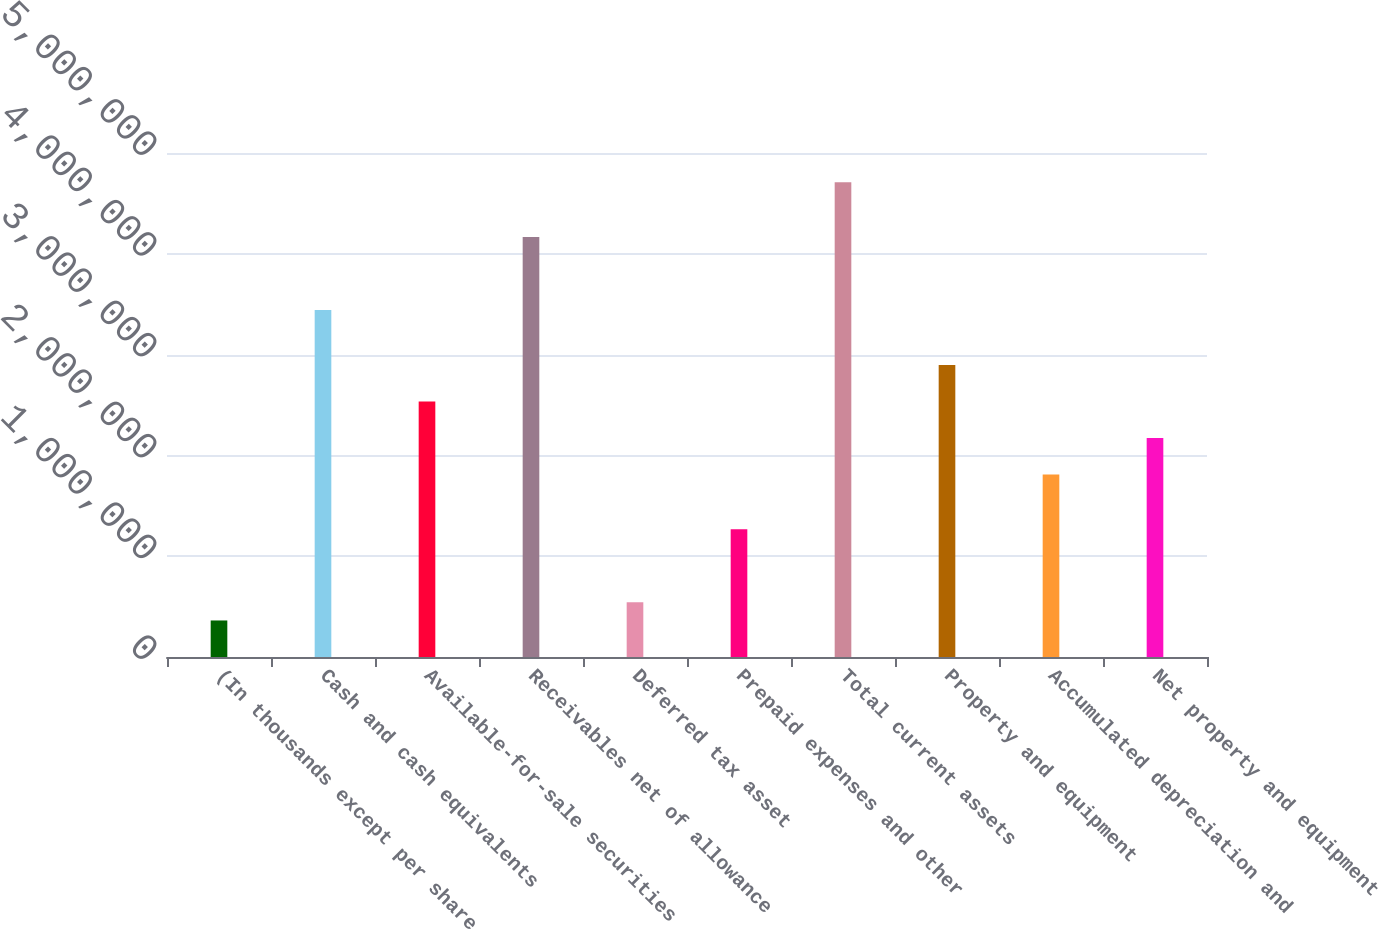Convert chart. <chart><loc_0><loc_0><loc_500><loc_500><bar_chart><fcel>(In thousands except per share<fcel>Cash and cash equivalents<fcel>Available-for-sale securities<fcel>Receivables net of allowance<fcel>Deferred tax asset<fcel>Prepaid expenses and other<fcel>Total current assets<fcel>Property and equipment<fcel>Accumulated depreciation and<fcel>Net property and equipment<nl><fcel>362472<fcel>3.44125e+06<fcel>2.53572e+06<fcel>4.16566e+06<fcel>543576<fcel>1.26799e+06<fcel>4.70898e+06<fcel>2.89793e+06<fcel>1.81131e+06<fcel>2.17352e+06<nl></chart> 